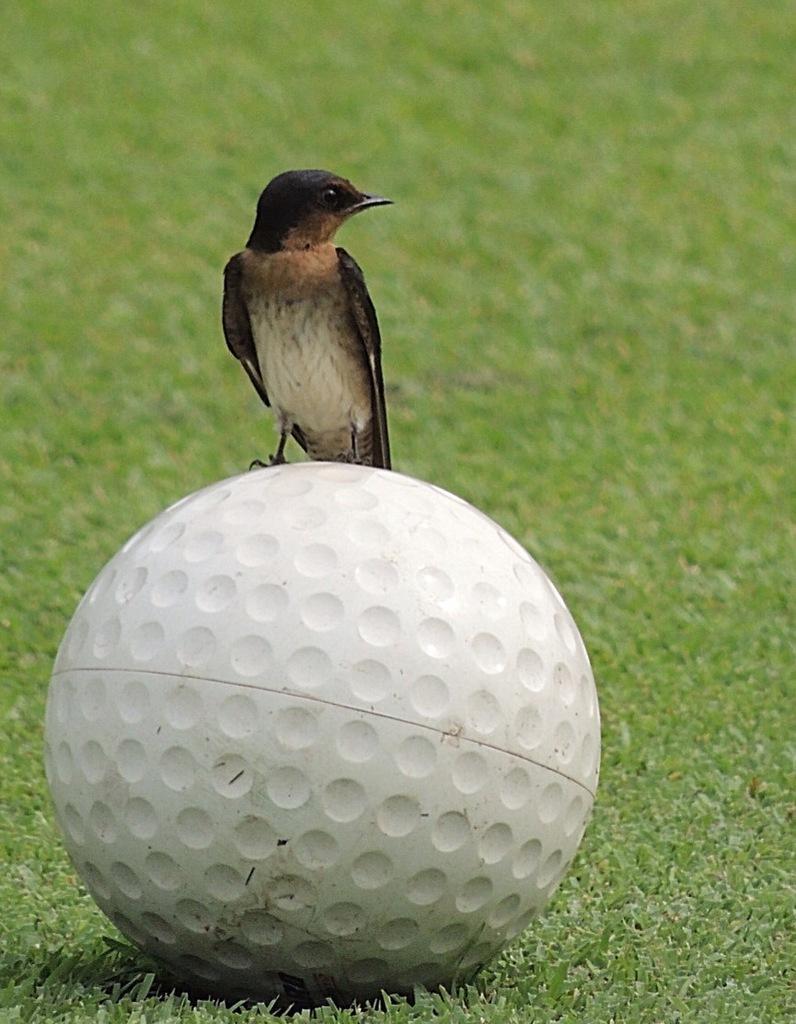How would you summarize this image in a sentence or two? In this picture we can see a bird on a ball and this ball is on the grass. 